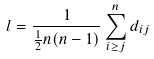Convert formula to latex. <formula><loc_0><loc_0><loc_500><loc_500>l = \frac { 1 } { \frac { 1 } { 2 } n ( n - 1 ) } \sum _ { i \geq j } ^ { n } d _ { i j }</formula> 